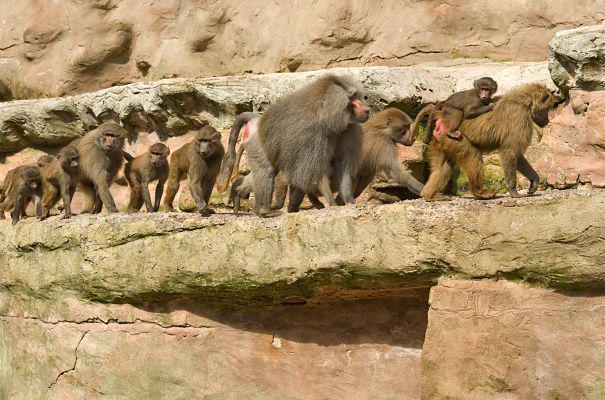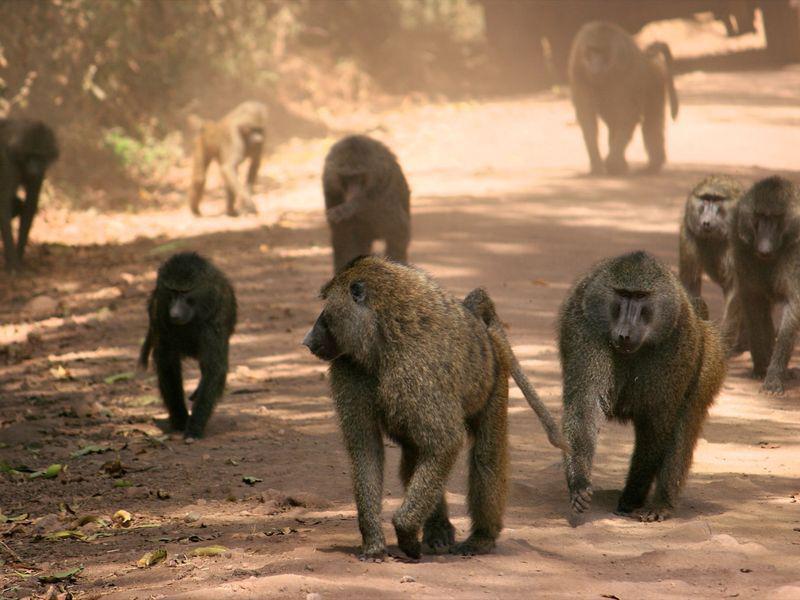The first image is the image on the left, the second image is the image on the right. Assess this claim about the two images: "One image is framed in black.". Correct or not? Answer yes or no. No. 